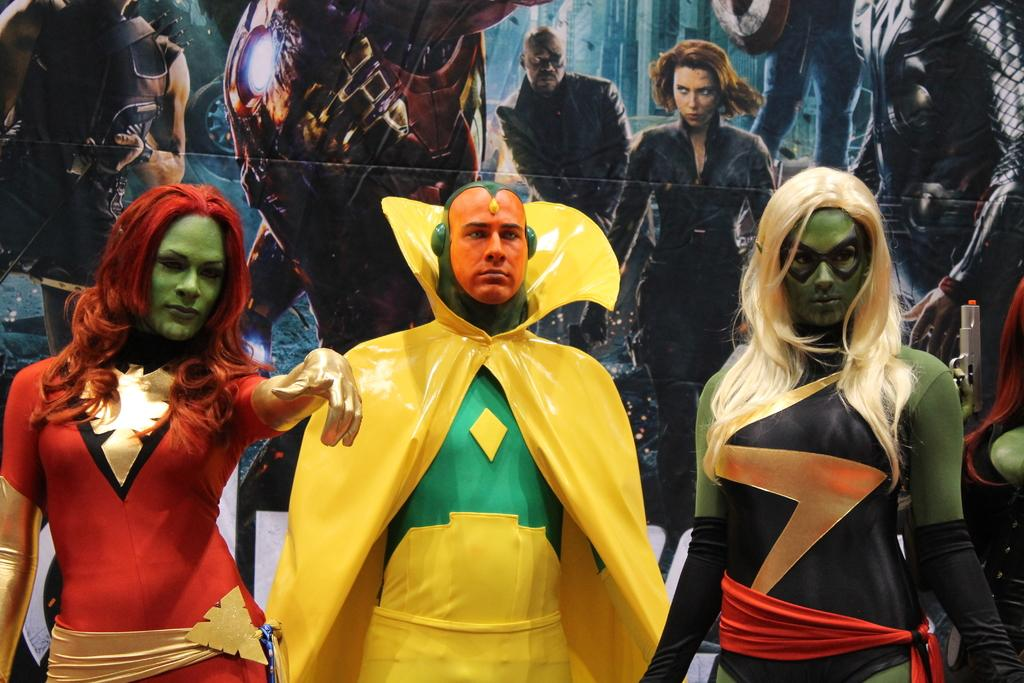Who is present in the image? There are men and women in the image. What are the men and women wearing? The men and women are dressed in performance costumes. What can be seen in the background of the image? There is an advertisement in the background of the image. How many frogs are sitting on the oranges in the image? There are no frogs or oranges present in the image. 